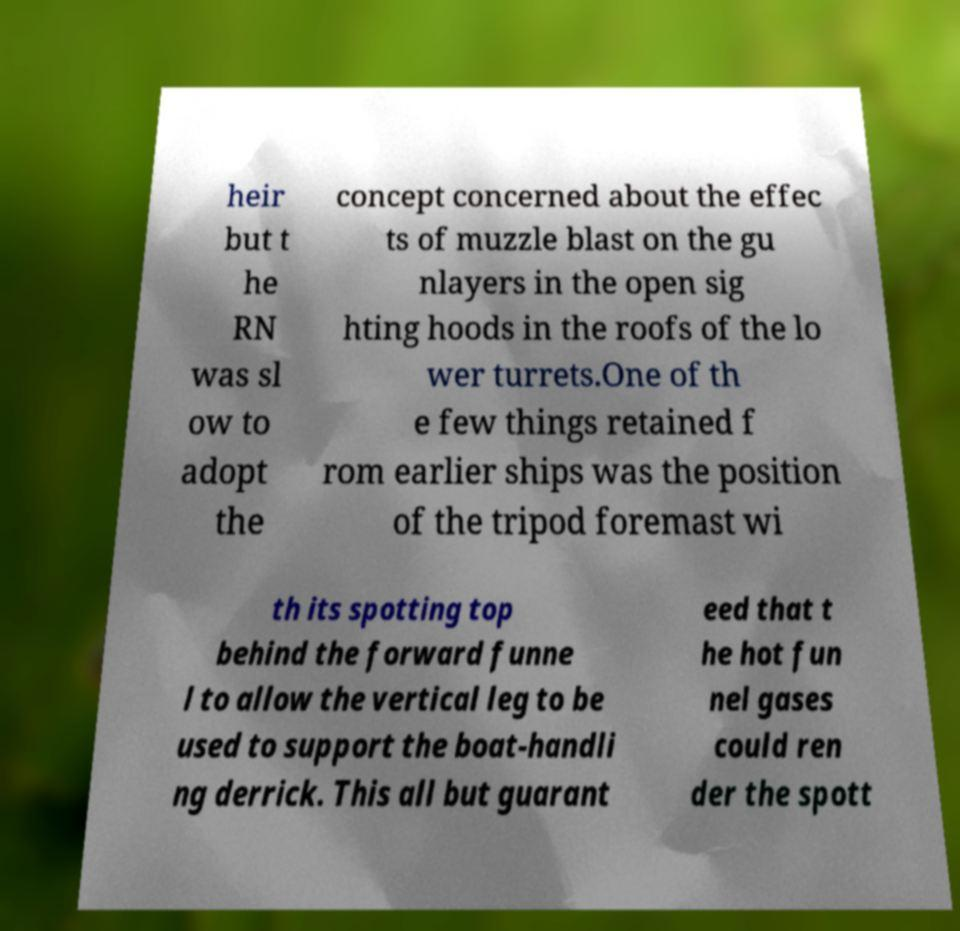For documentation purposes, I need the text within this image transcribed. Could you provide that? heir but t he RN was sl ow to adopt the concept concerned about the effec ts of muzzle blast on the gu nlayers in the open sig hting hoods in the roofs of the lo wer turrets.One of th e few things retained f rom earlier ships was the position of the tripod foremast wi th its spotting top behind the forward funne l to allow the vertical leg to be used to support the boat-handli ng derrick. This all but guarant eed that t he hot fun nel gases could ren der the spott 